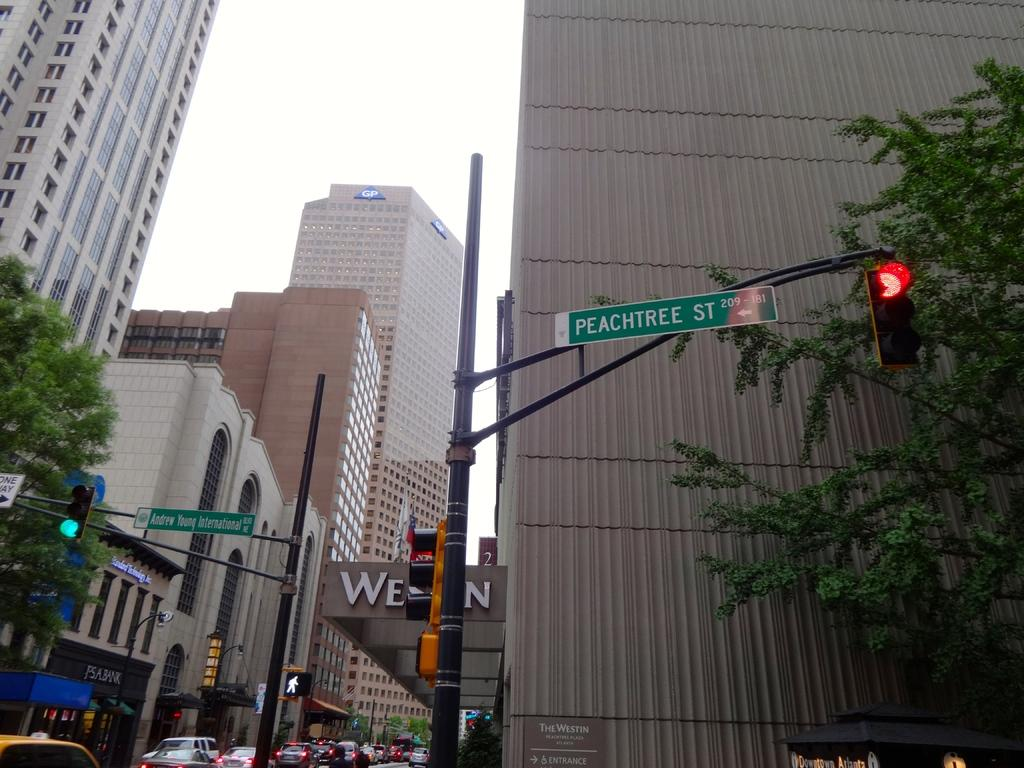<image>
Give a short and clear explanation of the subsequent image. A city intersection is shown:  Peachtree Street to the right foreground, and Andrew Young International Boulevard to the left into the background. 